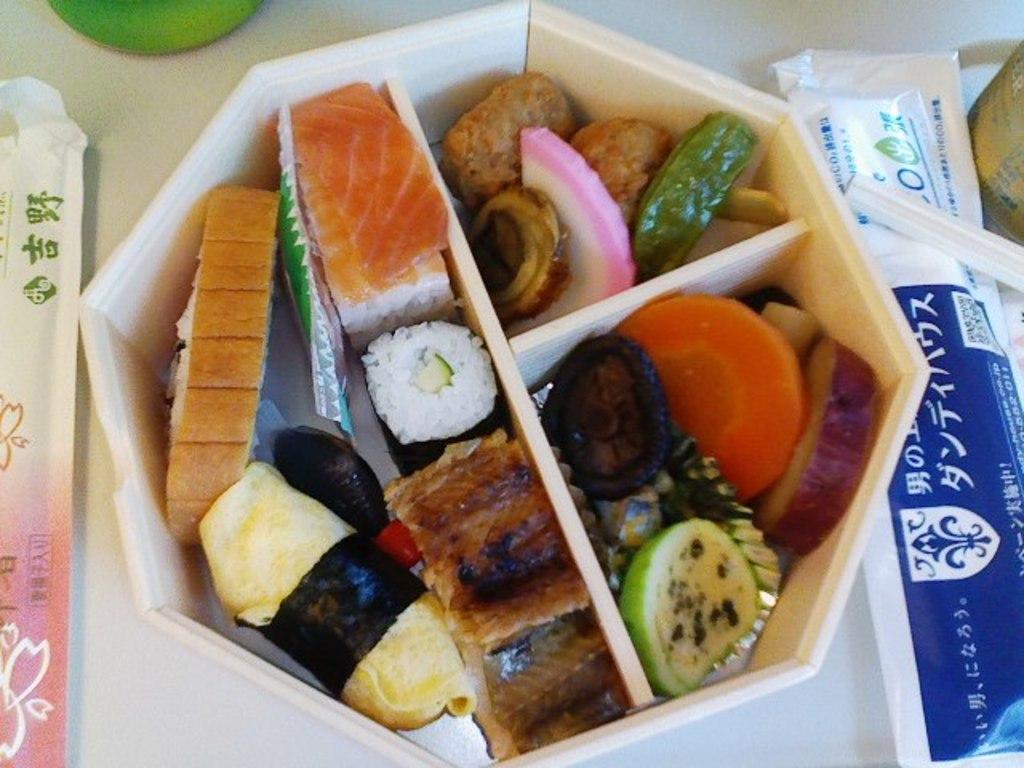Can you describe this image briefly? In this image we can see some food items in a box, there are some packets and other objects on the surface. 